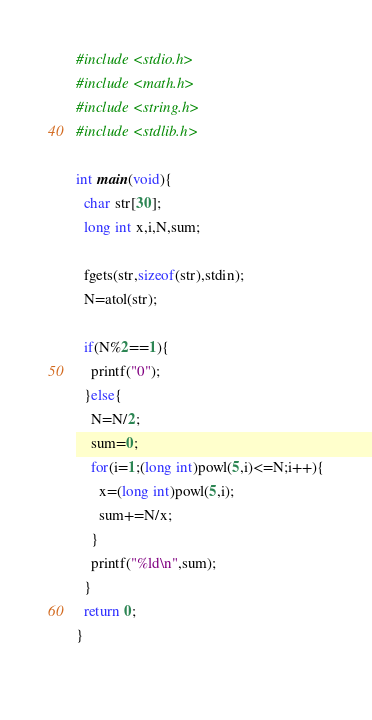Convert code to text. <code><loc_0><loc_0><loc_500><loc_500><_C_>#include <stdio.h>
#include <math.h>
#include <string.h>
#include <stdlib.h>

int main(void){
  char str[30];
  long int x,i,N,sum;
  
  fgets(str,sizeof(str),stdin);
  N=atol(str);
  
  if(N%2==1){
    printf("0");
  }else{
    N=N/2;
    sum=0;
    for(i=1;(long int)powl(5,i)<=N;i++){
      x=(long int)powl(5,i);
      sum+=N/x;
    }
    printf("%ld\n",sum);
  }
  return 0;
}
    </code> 